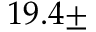<formula> <loc_0><loc_0><loc_500><loc_500>1 9 . 4 \pm</formula> 